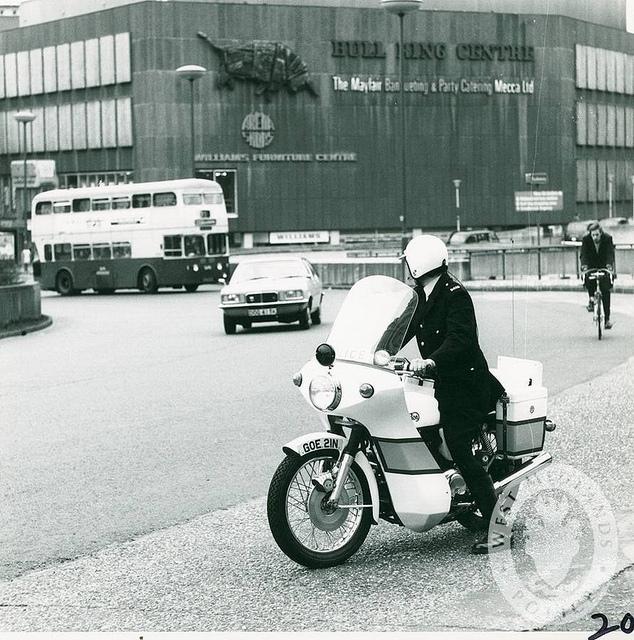Is the car moving?
Short answer required. Yes. What animal is depicted in the photo?
Be succinct. Dinosaur. What material is the building made out of?
Keep it brief. Concrete. What type of building is this?
Keep it brief. Bull ring center. Is this pic in black and white or color?
Short answer required. Black and white. 